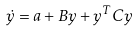Convert formula to latex. <formula><loc_0><loc_0><loc_500><loc_500>\dot { y } = a + B y + y ^ { T } C y</formula> 